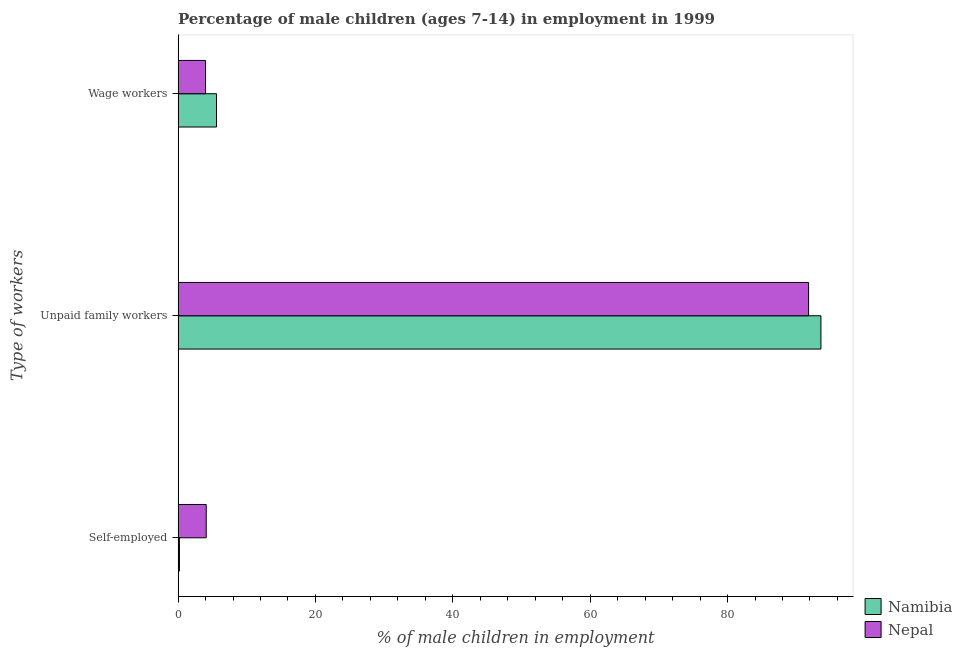How many different coloured bars are there?
Provide a short and direct response. 2. Are the number of bars per tick equal to the number of legend labels?
Keep it short and to the point. Yes. How many bars are there on the 1st tick from the top?
Ensure brevity in your answer.  2. What is the label of the 2nd group of bars from the top?
Provide a succinct answer. Unpaid family workers. What is the percentage of children employed as unpaid family workers in Nepal?
Your answer should be compact. 91.8. Across all countries, what is the maximum percentage of children employed as wage workers?
Give a very brief answer. 5.6. Across all countries, what is the minimum percentage of children employed as unpaid family workers?
Your response must be concise. 91.8. In which country was the percentage of children employed as wage workers maximum?
Your answer should be compact. Namibia. In which country was the percentage of self employed children minimum?
Your answer should be very brief. Namibia. What is the difference between the percentage of self employed children in Namibia and that in Nepal?
Give a very brief answer. -3.9. What is the average percentage of self employed children per country?
Provide a succinct answer. 2.15. What is the difference between the percentage of children employed as unpaid family workers and percentage of self employed children in Nepal?
Your answer should be compact. 87.7. In how many countries, is the percentage of self employed children greater than 44 %?
Your answer should be compact. 0. What is the ratio of the percentage of self employed children in Namibia to that in Nepal?
Offer a very short reply. 0.05. Is the difference between the percentage of children employed as unpaid family workers in Namibia and Nepal greater than the difference between the percentage of self employed children in Namibia and Nepal?
Offer a very short reply. Yes. What is the difference between the highest and the second highest percentage of children employed as unpaid family workers?
Provide a succinct answer. 1.8. What is the difference between the highest and the lowest percentage of children employed as wage workers?
Your response must be concise. 1.6. In how many countries, is the percentage of children employed as unpaid family workers greater than the average percentage of children employed as unpaid family workers taken over all countries?
Give a very brief answer. 1. What does the 1st bar from the top in Wage workers represents?
Your answer should be compact. Nepal. What does the 1st bar from the bottom in Self-employed represents?
Your answer should be very brief. Namibia. Is it the case that in every country, the sum of the percentage of self employed children and percentage of children employed as unpaid family workers is greater than the percentage of children employed as wage workers?
Your answer should be compact. Yes. How many countries are there in the graph?
Keep it short and to the point. 2. Are the values on the major ticks of X-axis written in scientific E-notation?
Offer a terse response. No. Does the graph contain any zero values?
Offer a very short reply. No. Where does the legend appear in the graph?
Your response must be concise. Bottom right. What is the title of the graph?
Your answer should be compact. Percentage of male children (ages 7-14) in employment in 1999. Does "Armenia" appear as one of the legend labels in the graph?
Keep it short and to the point. No. What is the label or title of the X-axis?
Your response must be concise. % of male children in employment. What is the label or title of the Y-axis?
Your answer should be compact. Type of workers. What is the % of male children in employment in Namibia in Unpaid family workers?
Your answer should be compact. 93.6. What is the % of male children in employment of Nepal in Unpaid family workers?
Your response must be concise. 91.8. Across all Type of workers, what is the maximum % of male children in employment in Namibia?
Offer a terse response. 93.6. Across all Type of workers, what is the maximum % of male children in employment of Nepal?
Keep it short and to the point. 91.8. Across all Type of workers, what is the minimum % of male children in employment in Namibia?
Ensure brevity in your answer.  0.2. What is the total % of male children in employment in Namibia in the graph?
Your response must be concise. 99.4. What is the total % of male children in employment in Nepal in the graph?
Ensure brevity in your answer.  99.9. What is the difference between the % of male children in employment of Namibia in Self-employed and that in Unpaid family workers?
Keep it short and to the point. -93.4. What is the difference between the % of male children in employment in Nepal in Self-employed and that in Unpaid family workers?
Offer a very short reply. -87.7. What is the difference between the % of male children in employment of Namibia in Unpaid family workers and that in Wage workers?
Give a very brief answer. 88. What is the difference between the % of male children in employment in Nepal in Unpaid family workers and that in Wage workers?
Your answer should be very brief. 87.8. What is the difference between the % of male children in employment in Namibia in Self-employed and the % of male children in employment in Nepal in Unpaid family workers?
Keep it short and to the point. -91.6. What is the difference between the % of male children in employment in Namibia in Self-employed and the % of male children in employment in Nepal in Wage workers?
Your response must be concise. -3.8. What is the difference between the % of male children in employment of Namibia in Unpaid family workers and the % of male children in employment of Nepal in Wage workers?
Your response must be concise. 89.6. What is the average % of male children in employment of Namibia per Type of workers?
Provide a short and direct response. 33.13. What is the average % of male children in employment in Nepal per Type of workers?
Provide a succinct answer. 33.3. What is the difference between the % of male children in employment of Namibia and % of male children in employment of Nepal in Self-employed?
Provide a succinct answer. -3.9. What is the ratio of the % of male children in employment of Namibia in Self-employed to that in Unpaid family workers?
Your answer should be very brief. 0. What is the ratio of the % of male children in employment of Nepal in Self-employed to that in Unpaid family workers?
Give a very brief answer. 0.04. What is the ratio of the % of male children in employment in Namibia in Self-employed to that in Wage workers?
Make the answer very short. 0.04. What is the ratio of the % of male children in employment of Nepal in Self-employed to that in Wage workers?
Your answer should be compact. 1.02. What is the ratio of the % of male children in employment in Namibia in Unpaid family workers to that in Wage workers?
Your answer should be very brief. 16.71. What is the ratio of the % of male children in employment in Nepal in Unpaid family workers to that in Wage workers?
Ensure brevity in your answer.  22.95. What is the difference between the highest and the second highest % of male children in employment in Nepal?
Keep it short and to the point. 87.7. What is the difference between the highest and the lowest % of male children in employment of Namibia?
Keep it short and to the point. 93.4. What is the difference between the highest and the lowest % of male children in employment of Nepal?
Your answer should be very brief. 87.8. 